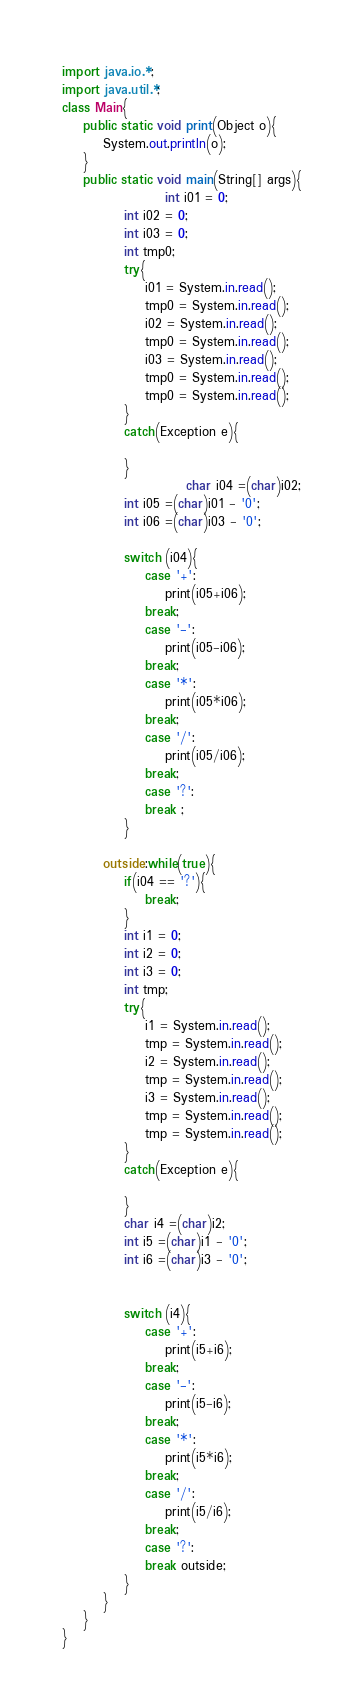Convert code to text. <code><loc_0><loc_0><loc_500><loc_500><_Java_>import java.io.*;
import java.util.*;
class Main{
	public static void print(Object o){
		System.out.println(o);
	}
	public static void main(String[] args){
					int i01 = 0;
			int i02 = 0;
			int i03 = 0;
			int tmp0;
			try{
				i01 = System.in.read();
				tmp0 = System.in.read();
				i02 = System.in.read();
				tmp0 = System.in.read();
				i03 = System.in.read();
				tmp0 = System.in.read();
				tmp0 = System.in.read();
			}
			catch(Exception e){
				
			}
						char i04 =(char)i02;
			int i05 =(char)i01 - '0';
			int i06 =(char)i03 - '0';
			
			switch (i04){
				case '+':
					print(i05+i06);
				break;
				case '-':
					print(i05-i06);
				break;
				case '*':
					print(i05*i06);
				break;
				case '/':
					print(i05/i06);
				break;
				case '?':
				break ;
			}

		outside:while(true){
			if(i04 == '?'){
				break;
			}
			int i1 = 0;
			int i2 = 0;
			int i3 = 0;
			int tmp;
			try{
				i1 = System.in.read();
				tmp = System.in.read();
				i2 = System.in.read();
				tmp = System.in.read();
				i3 = System.in.read();
				tmp = System.in.read();
				tmp = System.in.read();
			}
			catch(Exception e){
				
			}
			char i4 =(char)i2;
			int i5 =(char)i1 - '0';
			int i6 =(char)i3 - '0';
			

			switch (i4){
				case '+':
					print(i5+i6);
				break;
				case '-':
					print(i5-i6);
				break;
				case '*':
					print(i5*i6);
				break;
				case '/':
					print(i5/i6);
				break;
				case '?':
				break outside;
			}
		}
	}
}</code> 